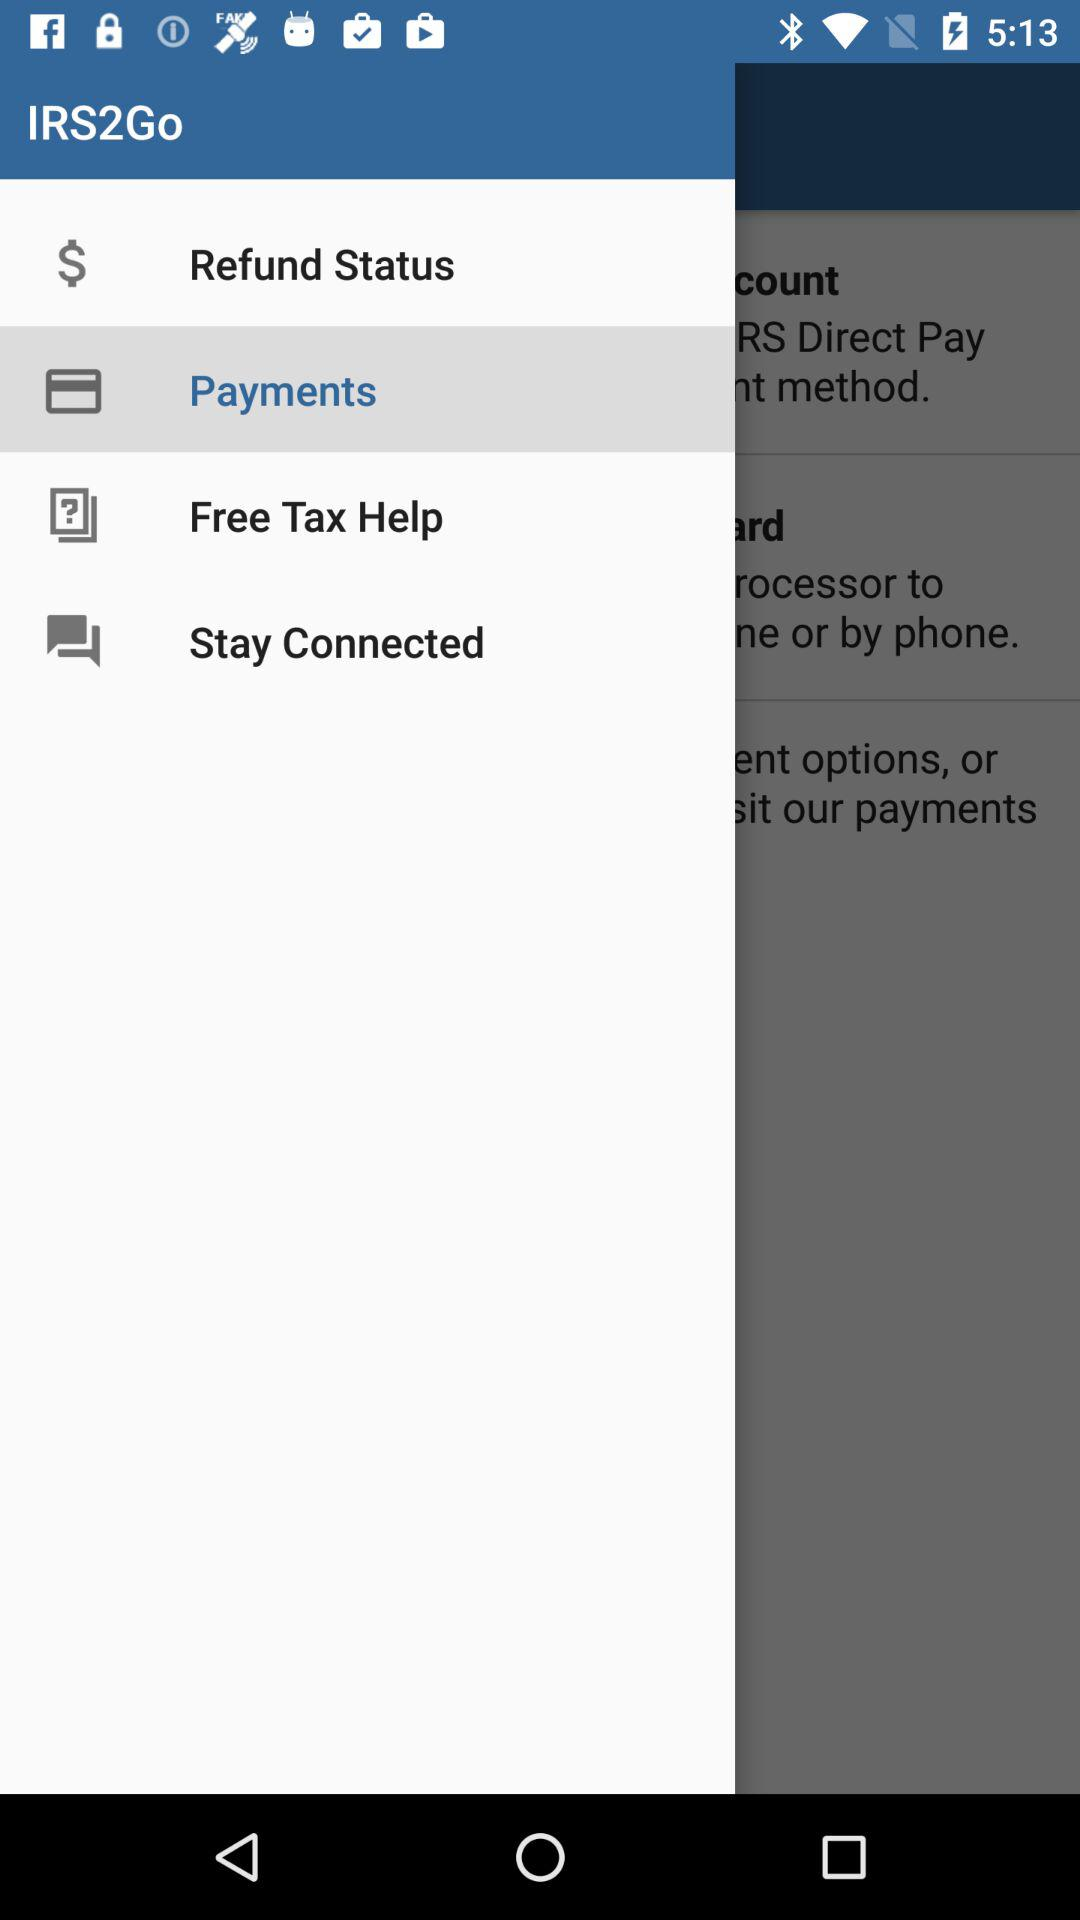What is the selected option? The selected option is "Payments". 